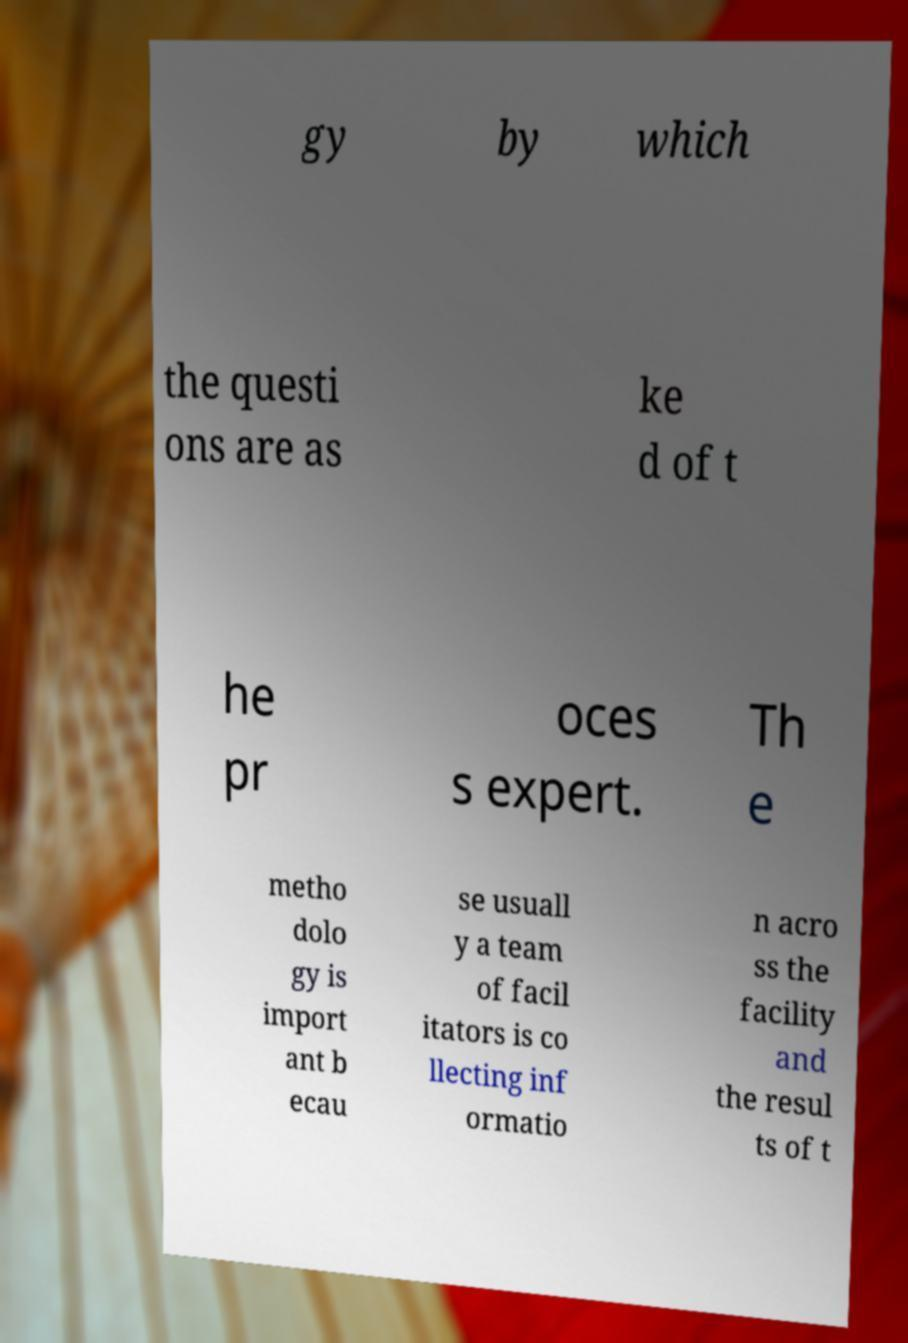Please identify and transcribe the text found in this image. gy by which the questi ons are as ke d of t he pr oces s expert. Th e metho dolo gy is import ant b ecau se usuall y a team of facil itators is co llecting inf ormatio n acro ss the facility and the resul ts of t 